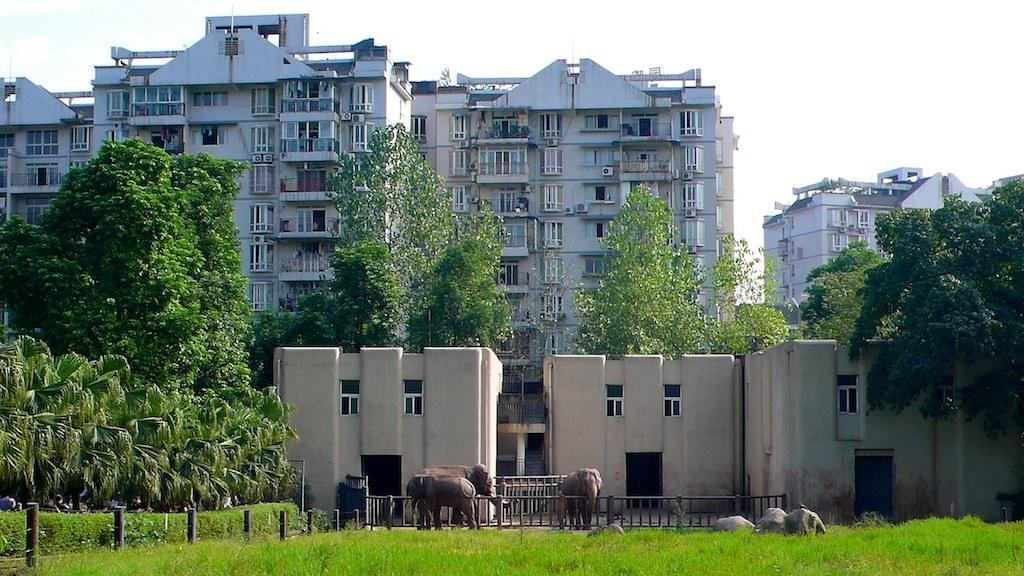How many elephants are present in the image? There are three elephants in the image. What are the elephants doing in the image? The elephants are standing in the image. What is surrounding the elephants? There is a fence around the elephants. What can be seen in the background of the image? There are buildings and trees in the background of the image. Where is the cobweb located in the image? There is no cobweb present in the image. Can you describe the sea visible in the image? There is no sea present in the image; it features three standing elephants surrounded by a fence, with buildings and trees in the background. 